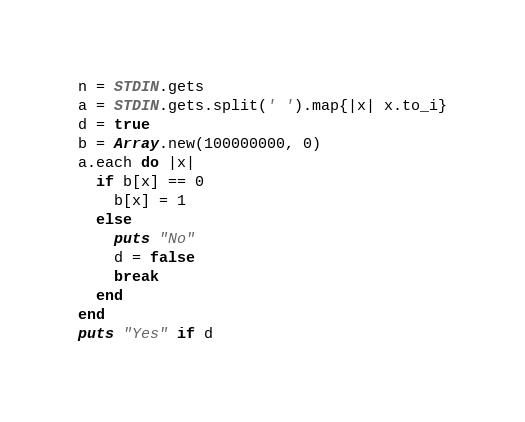<code> <loc_0><loc_0><loc_500><loc_500><_Ruby_>n = STDIN.gets
a = STDIN.gets.split(' ').map{|x| x.to_i}
d = true
b = Array.new(100000000, 0)
a.each do |x|
  if b[x] == 0
    b[x] = 1
  else
    puts "No"
    d = false
    break
  end
end
puts "Yes" if d</code> 